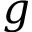Convert formula to latex. <formula><loc_0><loc_0><loc_500><loc_500>g</formula> 